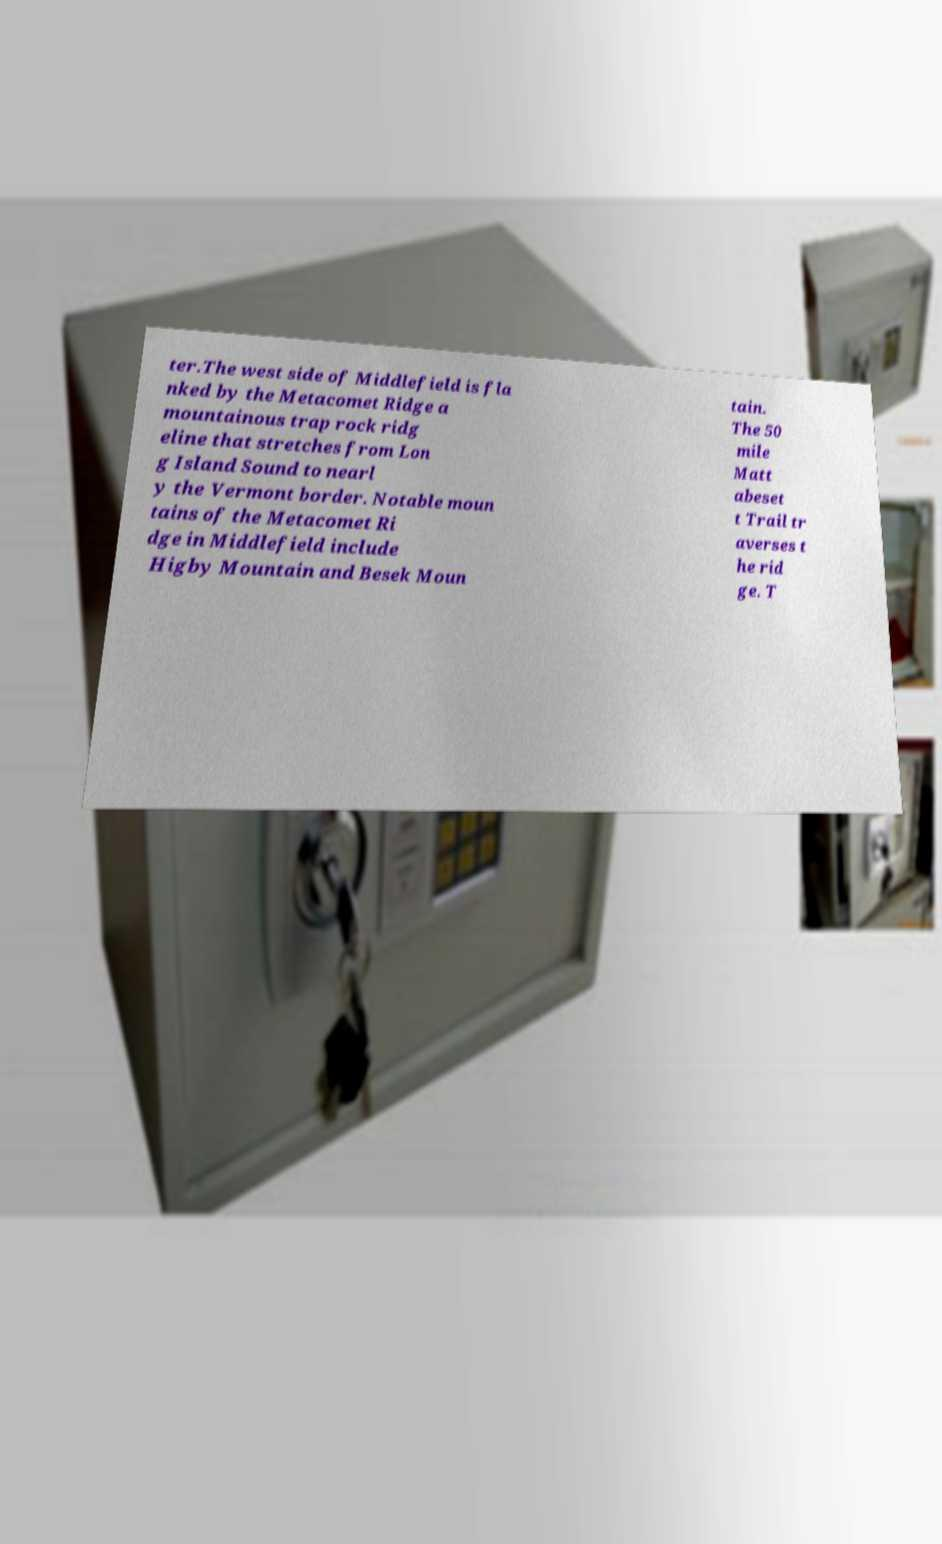Can you read and provide the text displayed in the image?This photo seems to have some interesting text. Can you extract and type it out for me? ter.The west side of Middlefield is fla nked by the Metacomet Ridge a mountainous trap rock ridg eline that stretches from Lon g Island Sound to nearl y the Vermont border. Notable moun tains of the Metacomet Ri dge in Middlefield include Higby Mountain and Besek Moun tain. The 50 mile Matt abeset t Trail tr averses t he rid ge. T 